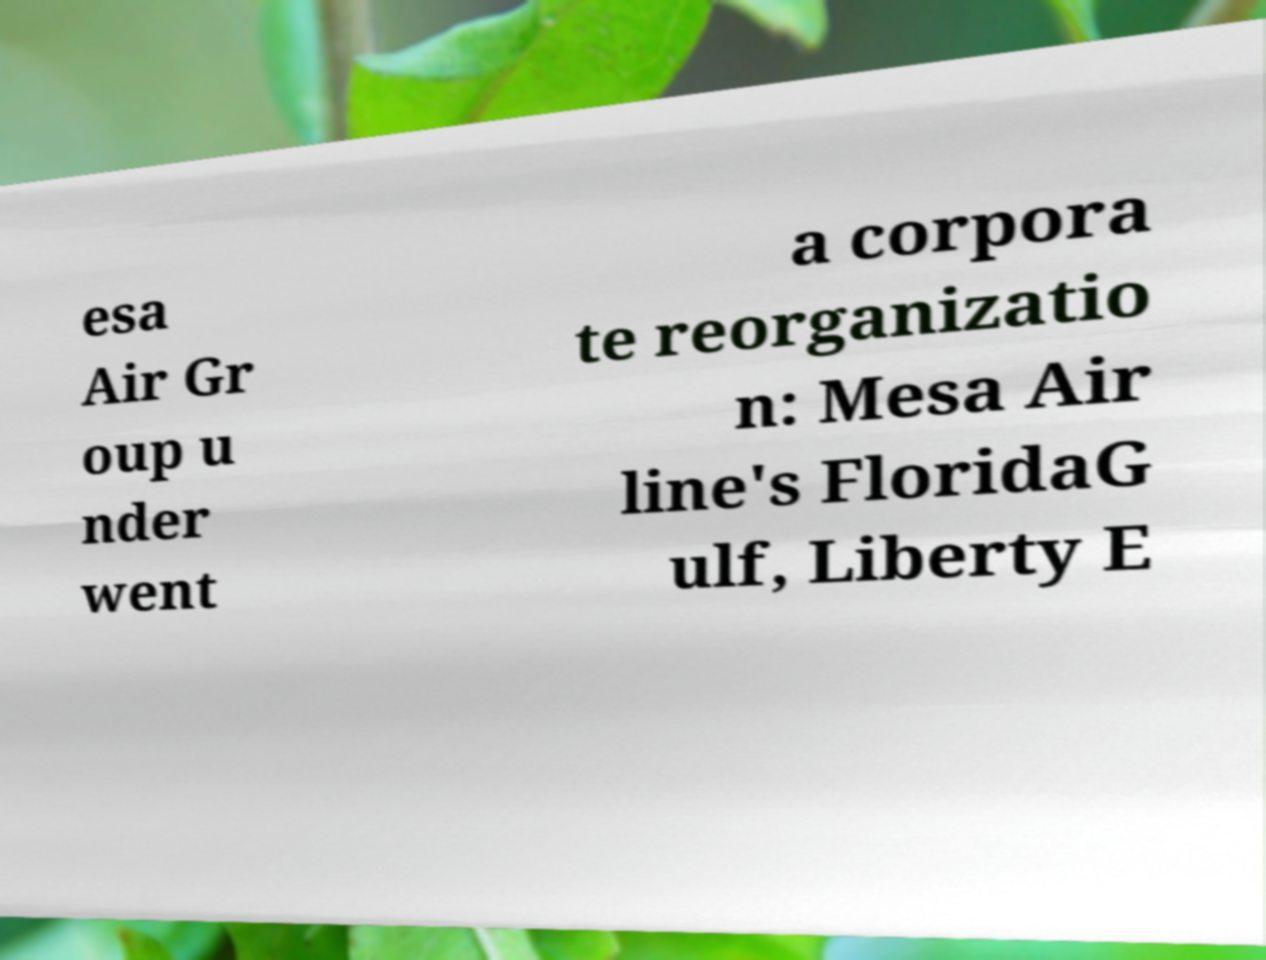I need the written content from this picture converted into text. Can you do that? esa Air Gr oup u nder went a corpora te reorganizatio n: Mesa Air line's FloridaG ulf, Liberty E 